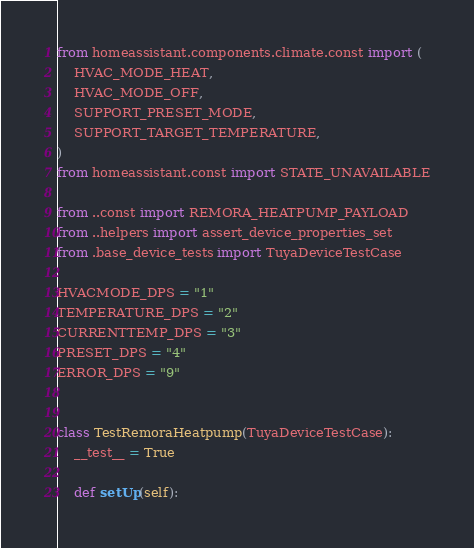Convert code to text. <code><loc_0><loc_0><loc_500><loc_500><_Python_>from homeassistant.components.climate.const import (
    HVAC_MODE_HEAT,
    HVAC_MODE_OFF,
    SUPPORT_PRESET_MODE,
    SUPPORT_TARGET_TEMPERATURE,
)
from homeassistant.const import STATE_UNAVAILABLE

from ..const import REMORA_HEATPUMP_PAYLOAD
from ..helpers import assert_device_properties_set
from .base_device_tests import TuyaDeviceTestCase

HVACMODE_DPS = "1"
TEMPERATURE_DPS = "2"
CURRENTTEMP_DPS = "3"
PRESET_DPS = "4"
ERROR_DPS = "9"


class TestRemoraHeatpump(TuyaDeviceTestCase):
    __test__ = True

    def setUp(self):</code> 